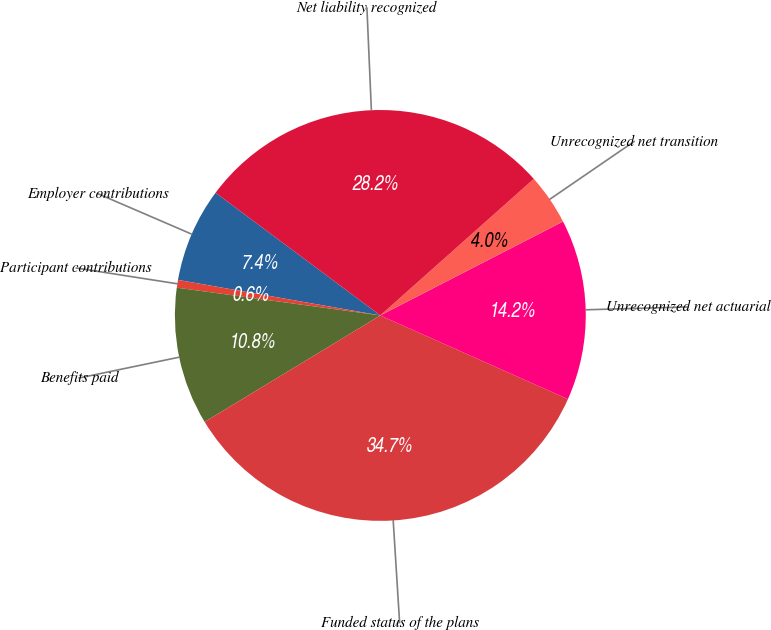Convert chart to OTSL. <chart><loc_0><loc_0><loc_500><loc_500><pie_chart><fcel>Employer contributions<fcel>Participant contributions<fcel>Benefits paid<fcel>Funded status of the plans<fcel>Unrecognized net actuarial<fcel>Unrecognized net transition<fcel>Net liability recognized<nl><fcel>7.42%<fcel>0.61%<fcel>10.83%<fcel>34.65%<fcel>14.23%<fcel>4.02%<fcel>28.24%<nl></chart> 